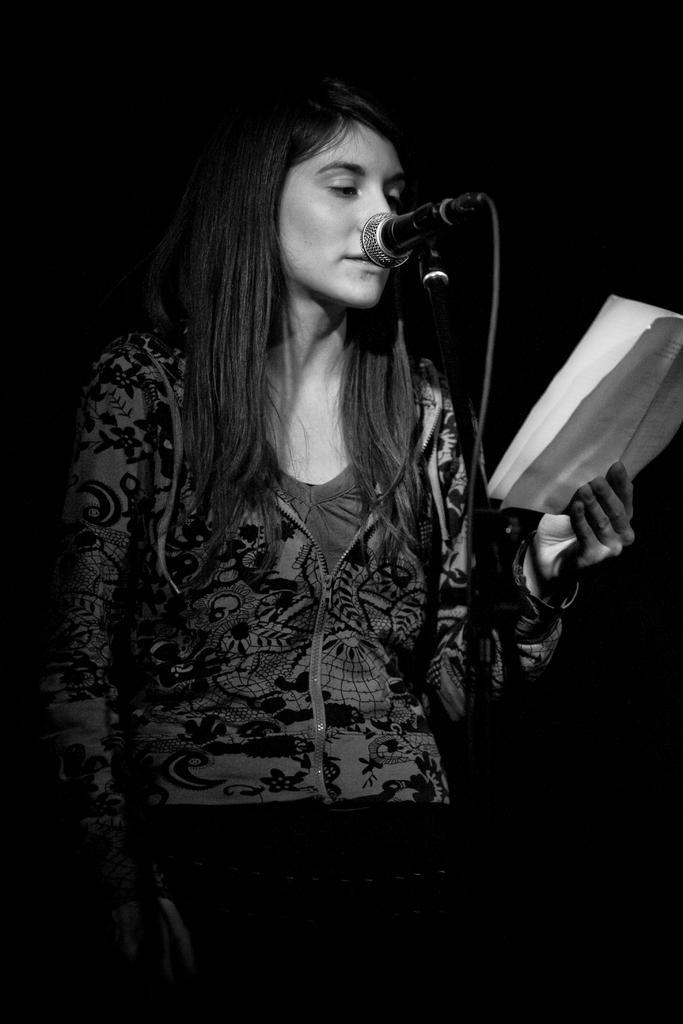Please provide a concise description of this image. In this image I can see a person standing and holding a paper and looking into it. And in front of her there is a microphone. 